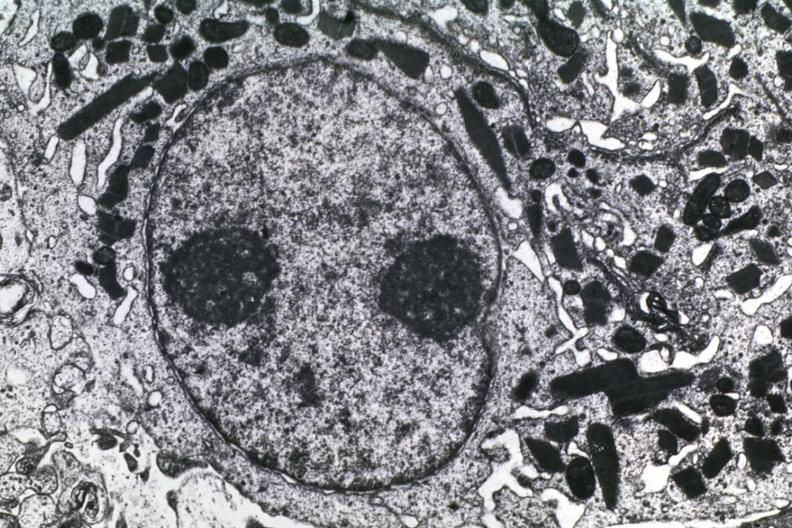does endocervical polyp show dr garcia tumors 57?
Answer the question using a single word or phrase. No 